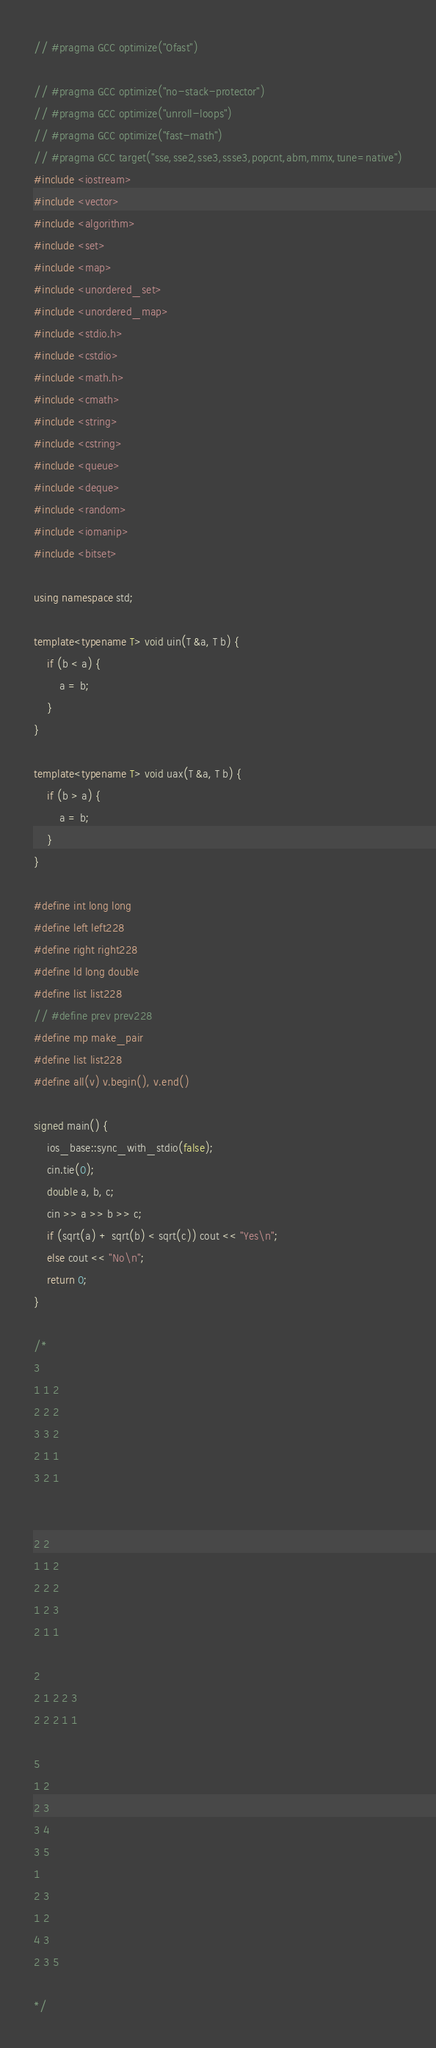Convert code to text. <code><loc_0><loc_0><loc_500><loc_500><_C++_>// #pragma GCC optimize("Ofast")

// #pragma GCC optimize("no-stack-protector")
// #pragma GCC optimize("unroll-loops")
// #pragma GCC optimize("fast-math")
// #pragma GCC target("sse,sse2,sse3,ssse3,popcnt,abm,mmx,tune=native")
#include <iostream>
#include <vector>
#include <algorithm>
#include <set>
#include <map>
#include <unordered_set>
#include <unordered_map>
#include <stdio.h>
#include <cstdio>
#include <math.h>
#include <cmath>
#include <string>
#include <cstring>
#include <queue>
#include <deque>
#include <random>
#include <iomanip>
#include <bitset>

using namespace std;

template<typename T> void uin(T &a, T b) {
    if (b < a) {
        a = b;
    }
}

template<typename T> void uax(T &a, T b) {
    if (b > a) {
        a = b;
    }
}

#define int long long
#define left left228
#define right right228
#define ld long double
#define list list228
// #define prev prev228
#define mp make_pair
#define list list228
#define all(v) v.begin(), v.end()

signed main() {
    ios_base::sync_with_stdio(false);
    cin.tie(0);
    double a, b, c;
    cin >> a >> b >> c;
    if (sqrt(a) + sqrt(b) < sqrt(c)) cout << "Yes\n";
    else cout << "No\n";
    return 0;
}

/*
3
1 1 2
2 2 2
3 3 2
2 1 1
3 2 1


2 2
1 1 2
2 2 2
1 2 3
2 1 1

2
2 1 2 2 3
2 2 2 1 1

5
1 2
2 3
3 4
3 5
1
2 3
1 2
4 3
2 3 5

*/

</code> 